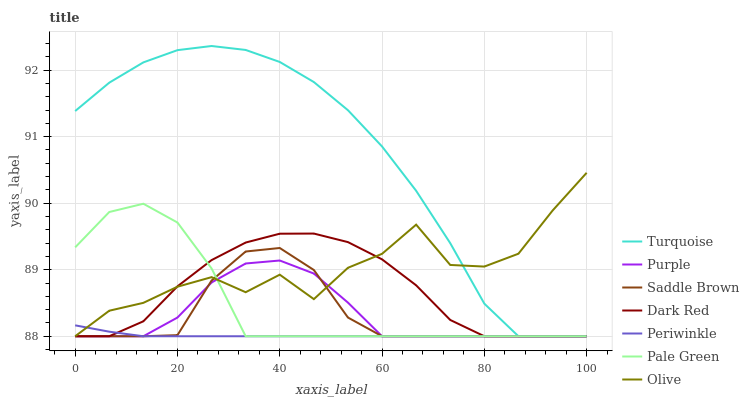Does Periwinkle have the minimum area under the curve?
Answer yes or no. Yes. Does Turquoise have the maximum area under the curve?
Answer yes or no. Yes. Does Purple have the minimum area under the curve?
Answer yes or no. No. Does Purple have the maximum area under the curve?
Answer yes or no. No. Is Periwinkle the smoothest?
Answer yes or no. Yes. Is Olive the roughest?
Answer yes or no. Yes. Is Purple the smoothest?
Answer yes or no. No. Is Purple the roughest?
Answer yes or no. No. Does Turquoise have the lowest value?
Answer yes or no. Yes. Does Turquoise have the highest value?
Answer yes or no. Yes. Does Purple have the highest value?
Answer yes or no. No. Does Turquoise intersect Pale Green?
Answer yes or no. Yes. Is Turquoise less than Pale Green?
Answer yes or no. No. Is Turquoise greater than Pale Green?
Answer yes or no. No. 